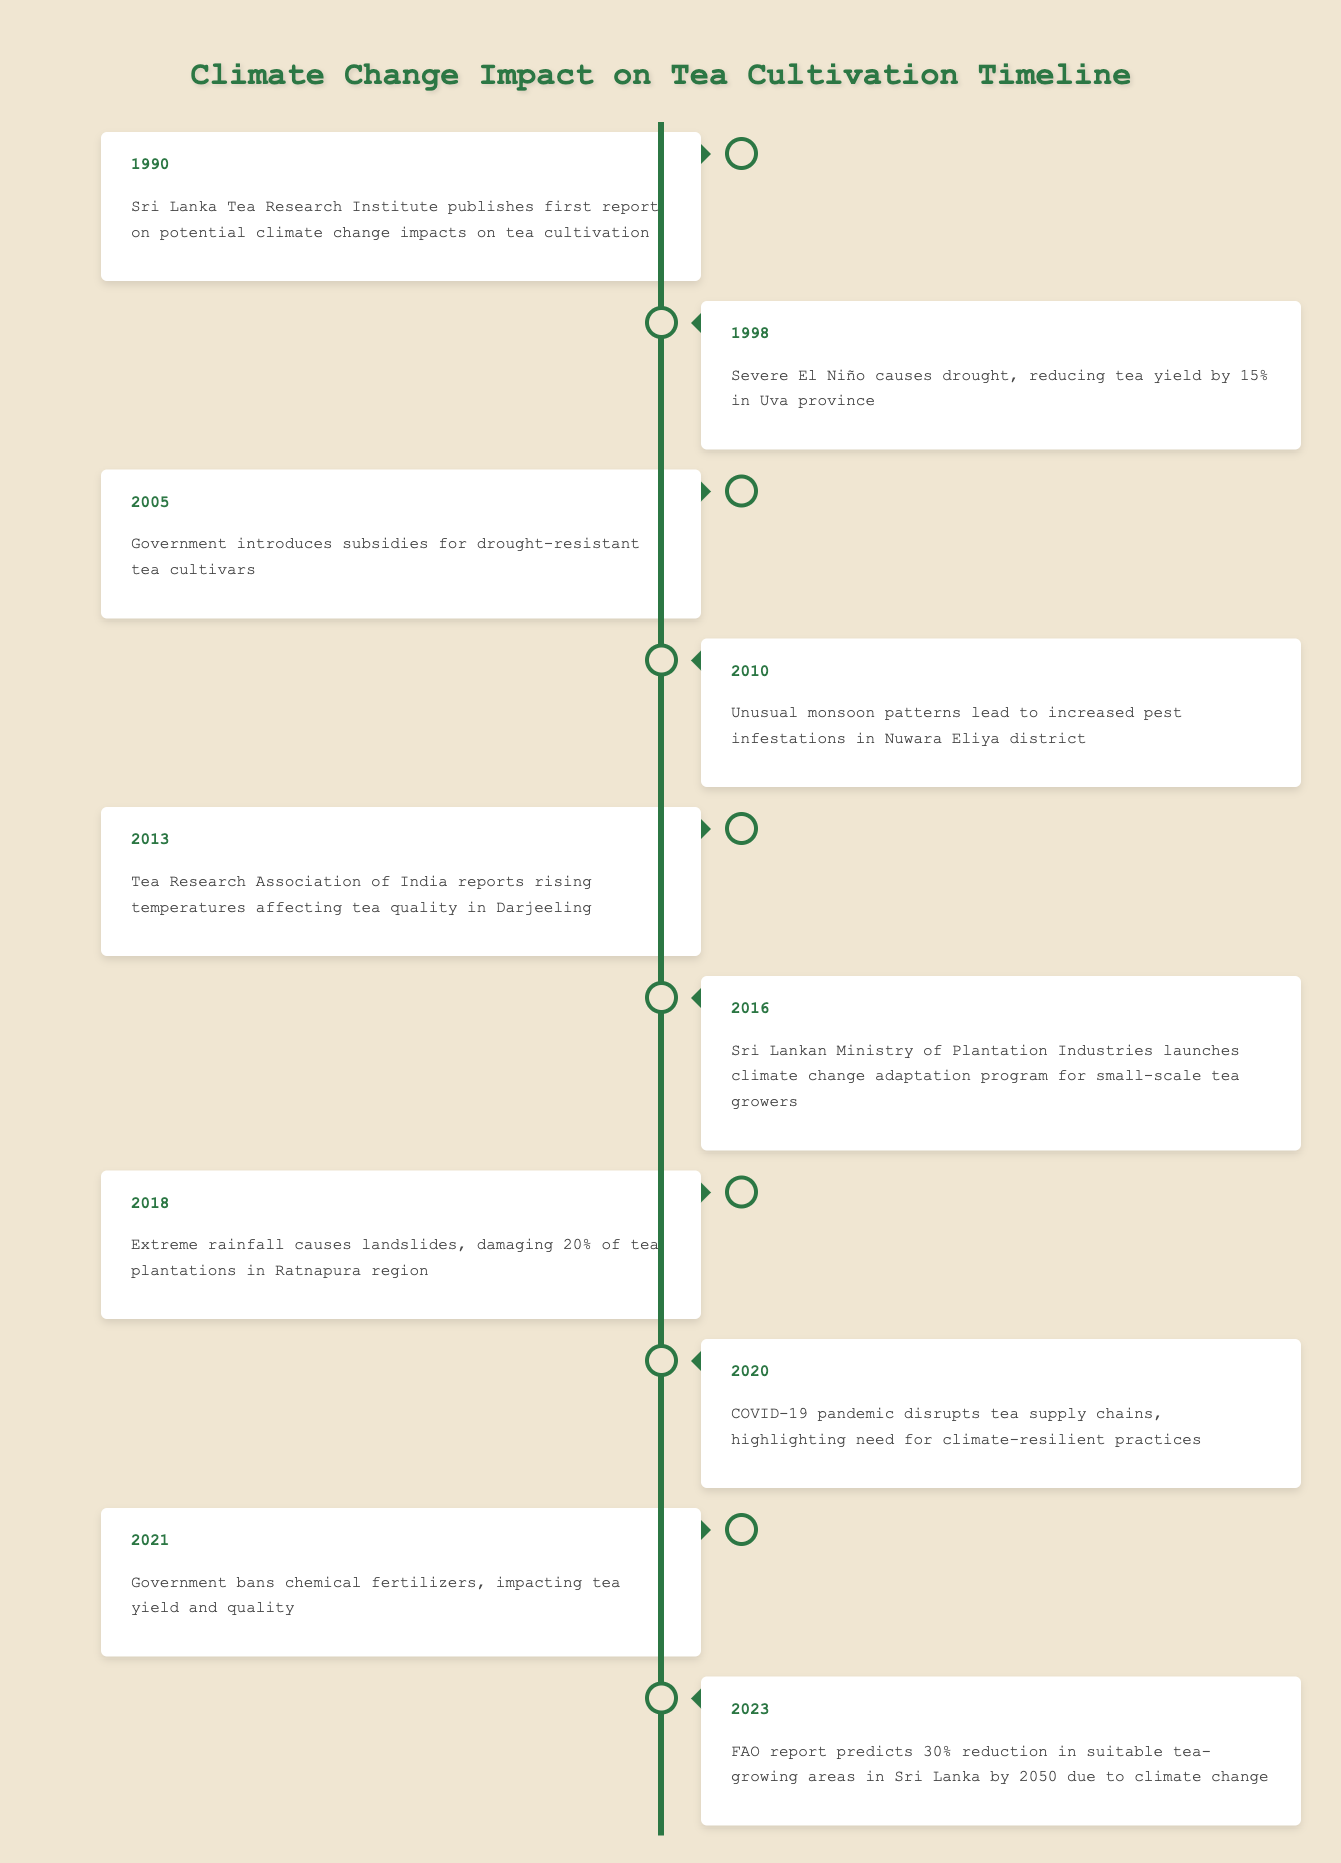What year did the Sri Lanka Tea Research Institute publish its first report on climate change impacts? The table shows that the Sri Lanka Tea Research Institute published its first report in 1990. This can be directly found in the first row under the year 1990.
Answer: 1990 What event occurred in 2010 that affected tea cultivation? According to the table, in 2010, unusual monsoon patterns led to increased pest infestations in the Nuwara Eliya district. This information is present in the entry for that year.
Answer: Unusual monsoon patterns lead to increased pest infestations in Nuwara Eliya district Did the year 2021 see any government policy that impacted tea cultivation? Yes, the data indicates that in 2021, the government banned chemical fertilizers, which had an effect on tea yield and quality. This can be confirmed through the specific event listed for that year.
Answer: Yes How many years are there between "Severe El Niño" in 1998 and the introduction of subsidies for drought-resistant tea cultivars in 2005? To find the number of years between these events, subtract 1998 from 2005, resulting in 7 years. This requires recognizing the years of the events listed in the table.
Answer: 7 According to the table, did tea quality in Darjeeling start being affected by rising temperatures after the year 2010? No, the table shows that the report on rising temperatures affecting tea quality in Darjeeling was made in 2013, which is after 2010, indicating that the issue was noticed later.
Answer: No What event in 2018 had significant physical impacts on tea plantations? The table notes that in 2018, extreme rainfall caused landslides that damaged 20% of tea plantations in the Ratnapura region. This shows a direct impact event for that year.
Answer: Extreme rainfall causes landslides, damaging 20% of tea plantations in Ratnapura region What was the impact of the COVID-19 pandemic in 2020 according to the table? The entry for 2020 indicates that the COVID-19 pandemic disrupted tea supply chains and highlighted the need for climate-resilient practices. This suggests a significant disruption in the industry that year.
Answer: COVID-19 pandemic disrupts tea supply chains, highlighting need for climate-resilient practices If the FAO predicts a 30% reduction in tea-growing areas by 2050, how many more years from 2023 until this prediction? The number of years from 2023 until 2050 can be calculated by subtracting 2023 from 2050, which gives 27 years. This involves a simple subtraction of the two years.
Answer: 27 